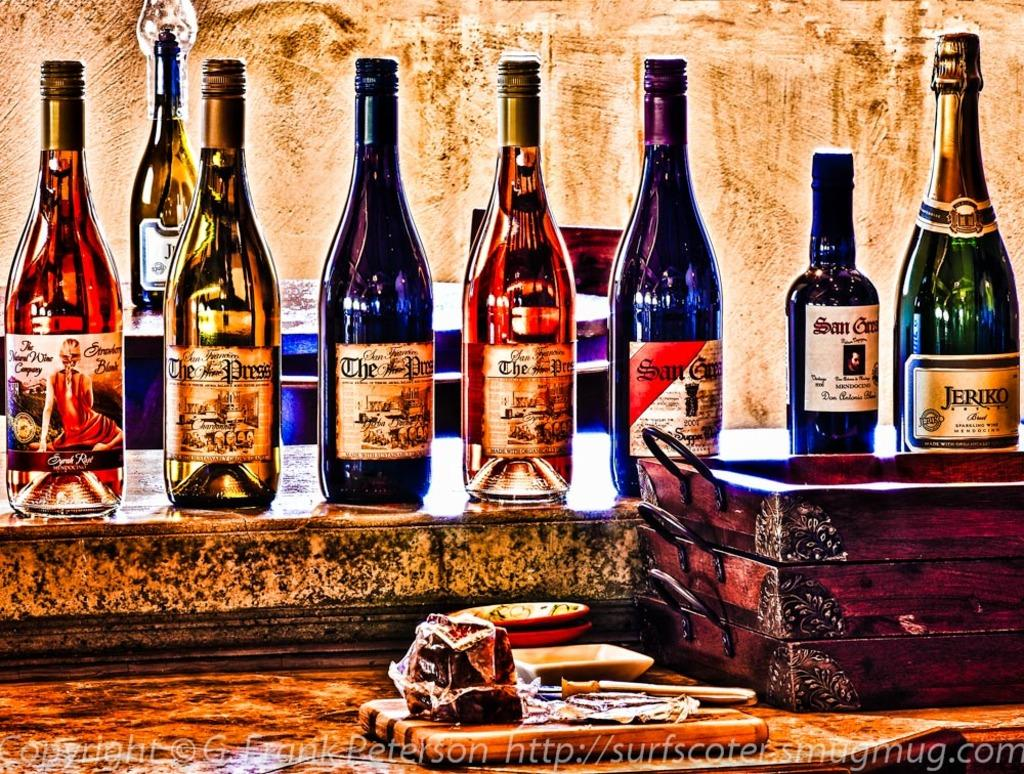<image>
Relay a brief, clear account of the picture shown. a painting of many wines has a bottle from the natural wine company 